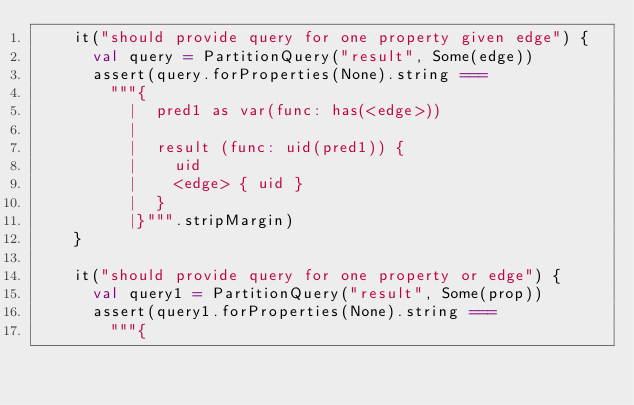<code> <loc_0><loc_0><loc_500><loc_500><_Scala_>    it("should provide query for one property given edge") {
      val query = PartitionQuery("result", Some(edge))
      assert(query.forProperties(None).string ===
        """{
          |  pred1 as var(func: has(<edge>))
          |
          |  result (func: uid(pred1)) {
          |    uid
          |    <edge> { uid }
          |  }
          |}""".stripMargin)
    }

    it("should provide query for one property or edge") {
      val query1 = PartitionQuery("result", Some(prop))
      assert(query1.forProperties(None).string ===
        """{</code> 